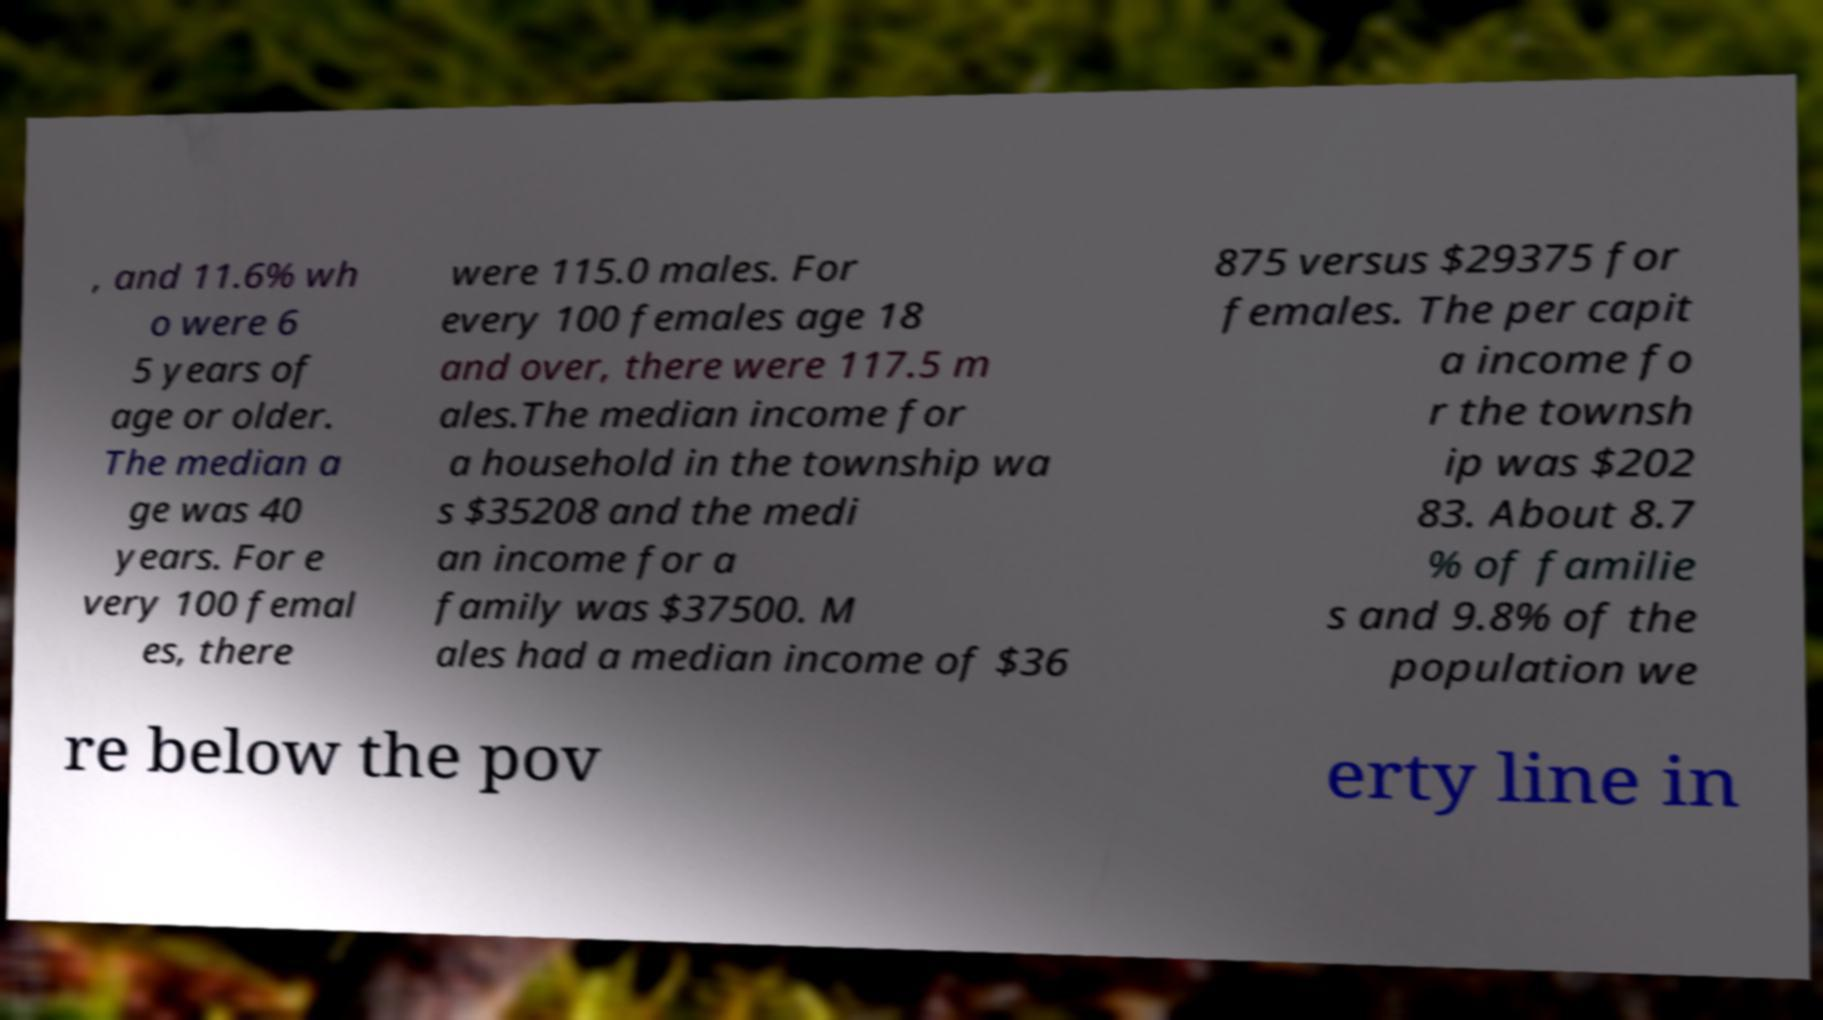Could you extract and type out the text from this image? , and 11.6% wh o were 6 5 years of age or older. The median a ge was 40 years. For e very 100 femal es, there were 115.0 males. For every 100 females age 18 and over, there were 117.5 m ales.The median income for a household in the township wa s $35208 and the medi an income for a family was $37500. M ales had a median income of $36 875 versus $29375 for females. The per capit a income fo r the townsh ip was $202 83. About 8.7 % of familie s and 9.8% of the population we re below the pov erty line in 